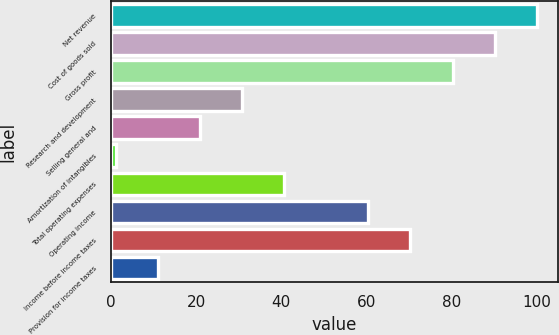Convert chart to OTSL. <chart><loc_0><loc_0><loc_500><loc_500><bar_chart><fcel>Net revenue<fcel>Cost of goods sold<fcel>Gross profit<fcel>Research and development<fcel>Selling general and<fcel>Amortization of intangibles<fcel>Total operating expenses<fcel>Operating income<fcel>Income before income taxes<fcel>Provision for income taxes<nl><fcel>100<fcel>90.11<fcel>80.22<fcel>30.77<fcel>20.88<fcel>1.1<fcel>40.66<fcel>60.44<fcel>70.33<fcel>10.99<nl></chart> 